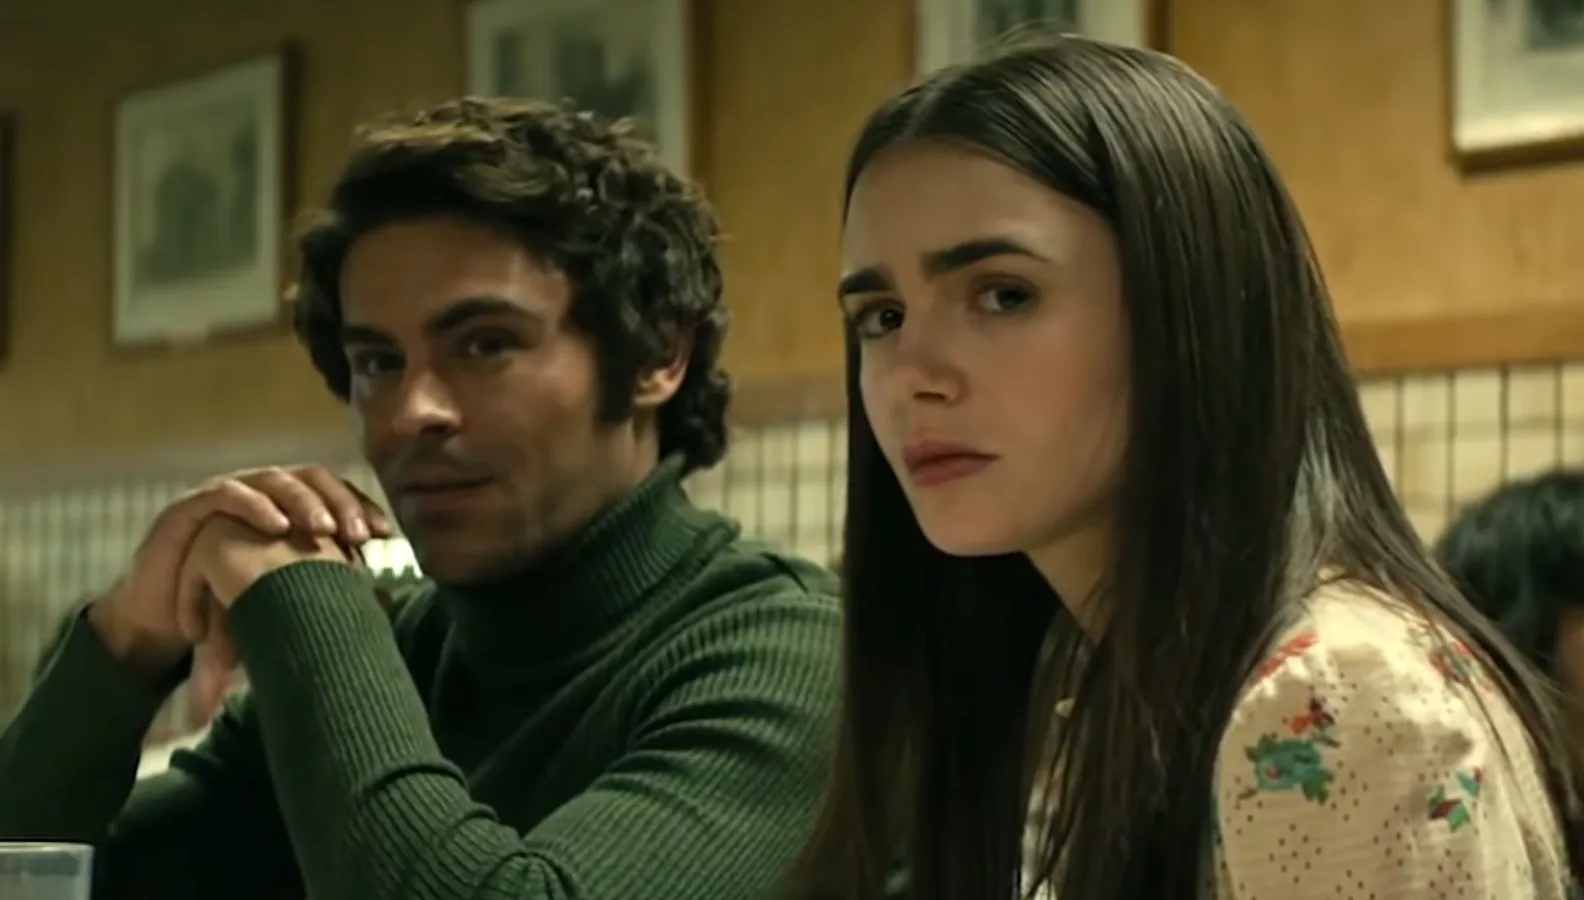Explain the visual content of the image in great detail. In this image, actors Zac Efron and Lily Collins are captured in a scene from a movie or TV show. They are seated in a diner, sharing a booth. Zac Efron, dressed in a green turtleneck sweater, is positioned on the left side of the frame. He rests his chin on his hand, his gaze directed towards the right side of the frame. On the right side of the frame, Lily Collins is seen wearing a white blouse adorned with a floral pattern. She, too, is looking off to the right side of the frame. Both actors wear serious expressions, adding a sense of gravity to the scene. The image encapsulates a moment of intense dialogue or contemplation between the two characters. 